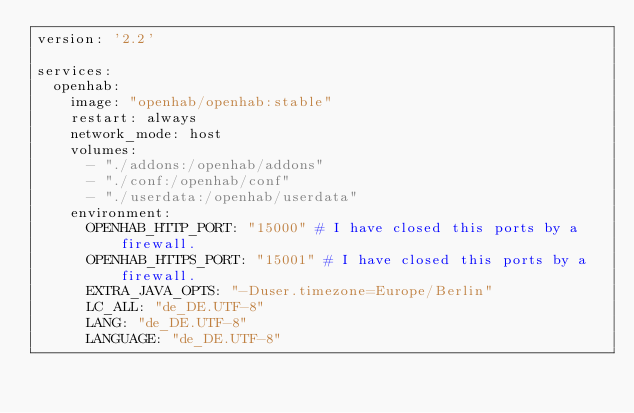Convert code to text. <code><loc_0><loc_0><loc_500><loc_500><_YAML_>version: '2.2'

services:
  openhab:
    image: "openhab/openhab:stable"
    restart: always
    network_mode: host
    volumes:
      - "./addons:/openhab/addons"
      - "./conf:/openhab/conf"
      - "./userdata:/openhab/userdata"
    environment:
      OPENHAB_HTTP_PORT: "15000" # I have closed this ports by a firewall.
      OPENHAB_HTTPS_PORT: "15001" # I have closed this ports by a firewall.
      EXTRA_JAVA_OPTS: "-Duser.timezone=Europe/Berlin"
      LC_ALL: "de_DE.UTF-8"
      LANG: "de_DE.UTF-8"
      LANGUAGE: "de_DE.UTF-8"
      
</code> 